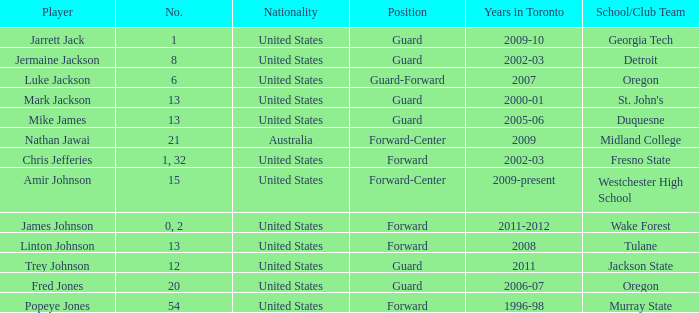In the 2006-07 season, what was the total count of positions for the toronto team? 1.0. 